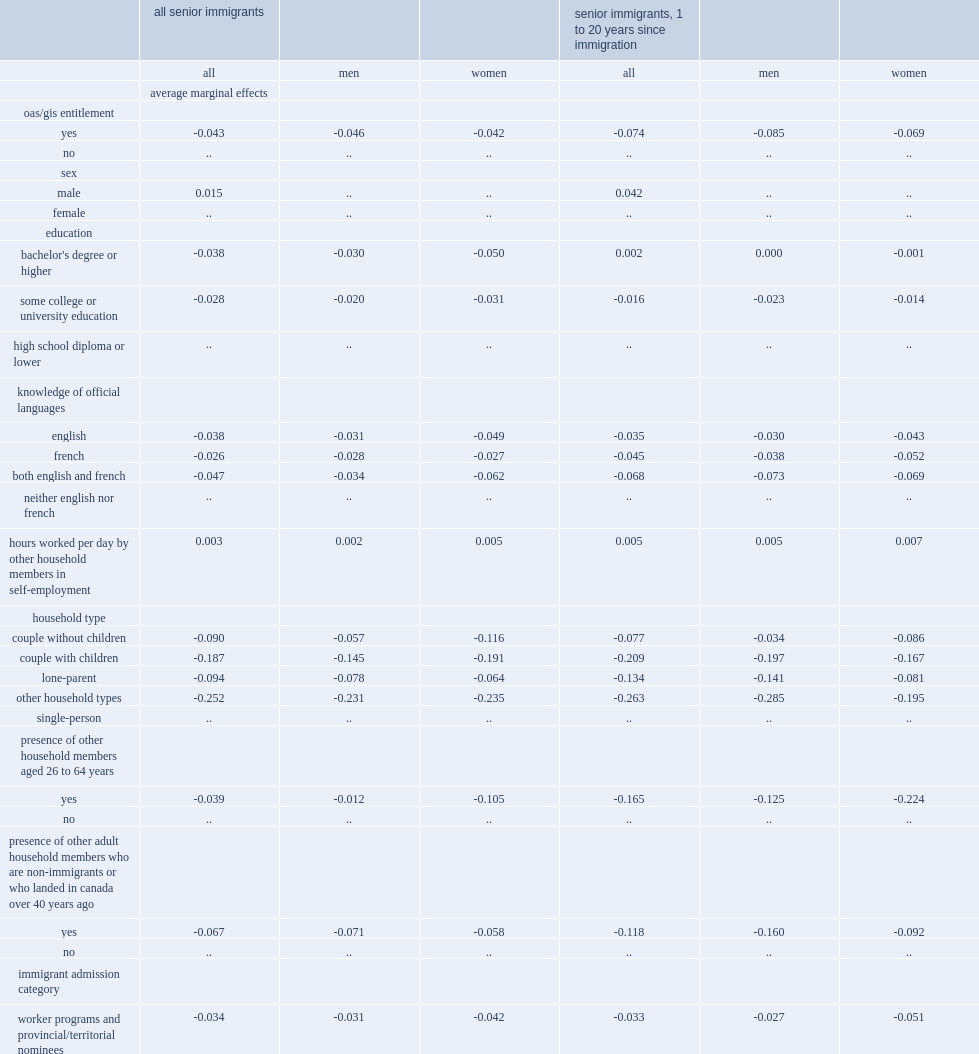What is the percentage of decline in results indicate that access to oas/gis reduces the low-income rate among all senior immigrants over the age of 65 after controlling for socioeconomic and demographic variables in 2016? 0.043. With all else held constant, what is the percentage of decline in the oas/gis reduces the low-income rate of seniors for men in 2016? 0.046. With all else held constant, what is the percentage of decline in the oas/gis reduces the low-income rate of seniors for women in 2016? 0.042. Access to the oas/gis was associated with what percentage of decline in the low-income rate for seniors who came to canada 1 to 20 years prior to the census in 2016? 0.074. 